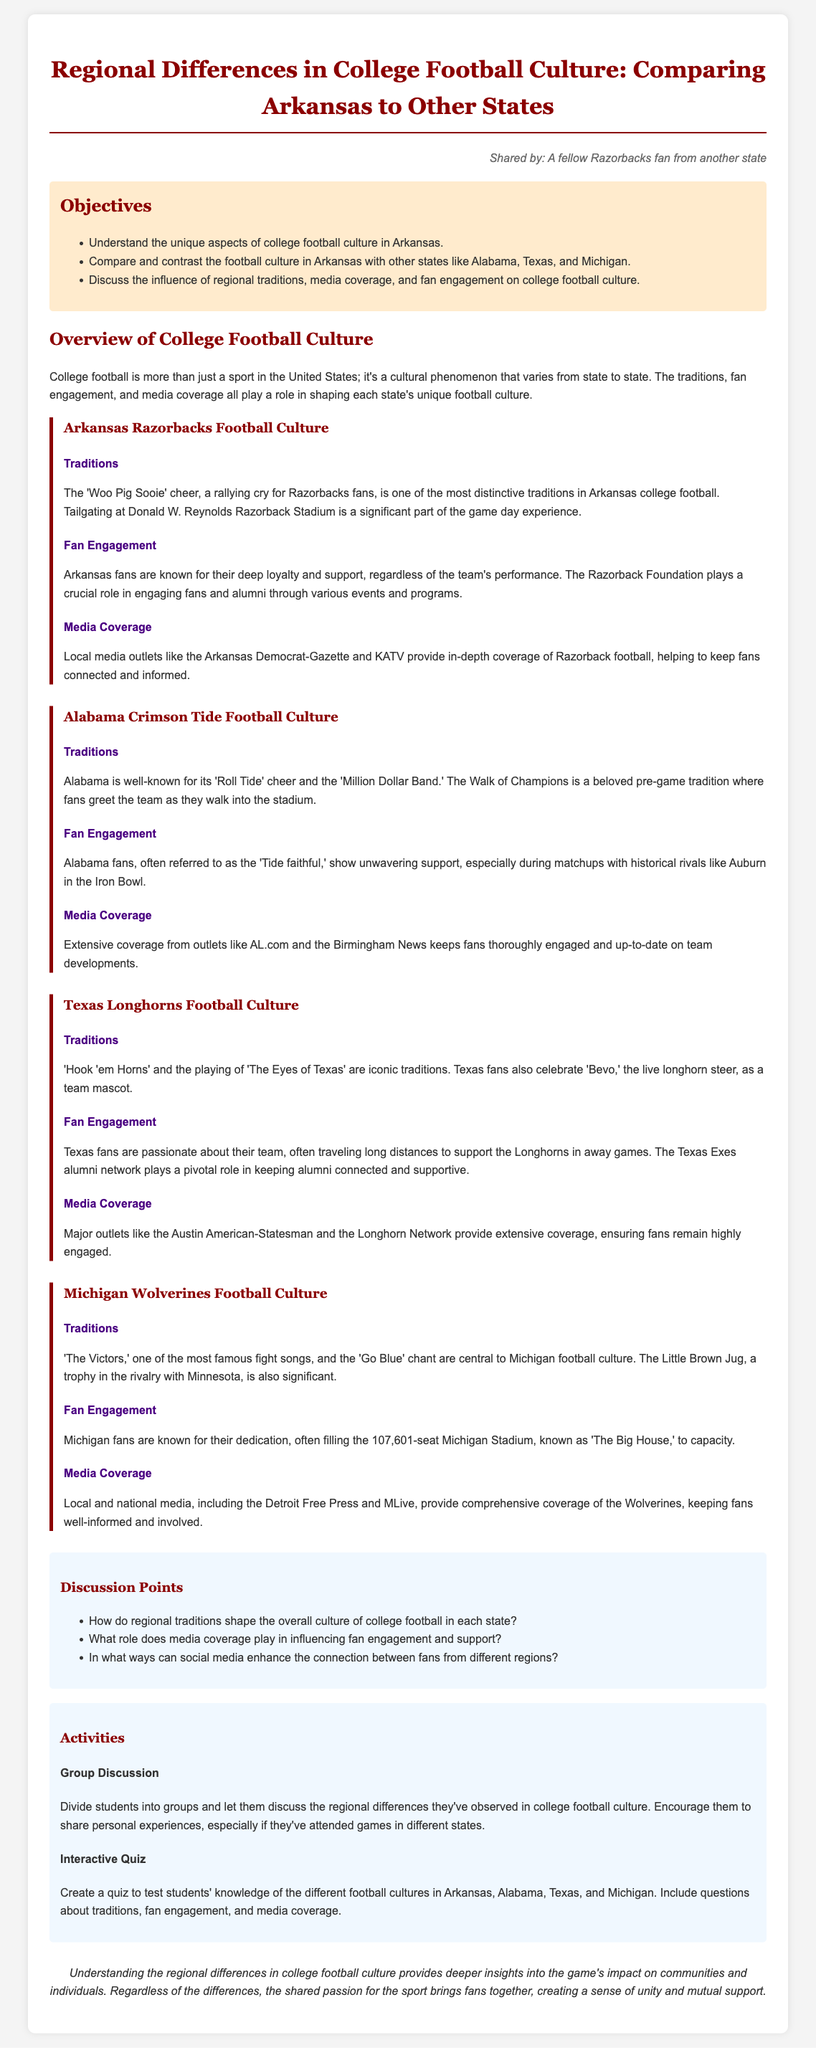What is the primary cheer for Arkansas fans? The document mentions that the 'Woo Pig Sooie' cheer is a distinctive tradition for Razorbacks fans.
Answer: Woo Pig Sooie Which state is compared to Arkansas in football culture? The document lists Alabama, Texas, and Michigan as states compared to Arkansas in the context of college football culture.
Answer: Alabama, Texas, and Michigan What role does the Razorback Foundation play? The Razorback Foundation is described as playing a crucial role in engaging fans and alumni through various events and programs.
Answer: Engaging fans and alumni What is the seating capacity of Michigan Stadium? The document states that Michigan Stadium, known as 'The Big House', has a seating capacity of 107,601.
Answer: 107,601 What purpose do the discussion points serve in the lesson plan? The discussion points are designed to facilitate conversation about regional traditions, media coverage, and social media's role in fan engagement.
Answer: Facilitate conversation How do Texas fans express their support at games? The document states that Texas fans often travel long distances to support the Longhorns in away games.
Answer: Travel long distances What is the iconic fight song for Michigan Wolverines? The document identifies 'The Victors' as one of the most famous fight songs associated with Michigan football culture.
Answer: The Victors What type of activity is suggested for student engagement? The document suggests a group discussion as well as an interactive quiz to engage students.
Answer: Group discussion and interactive quiz 